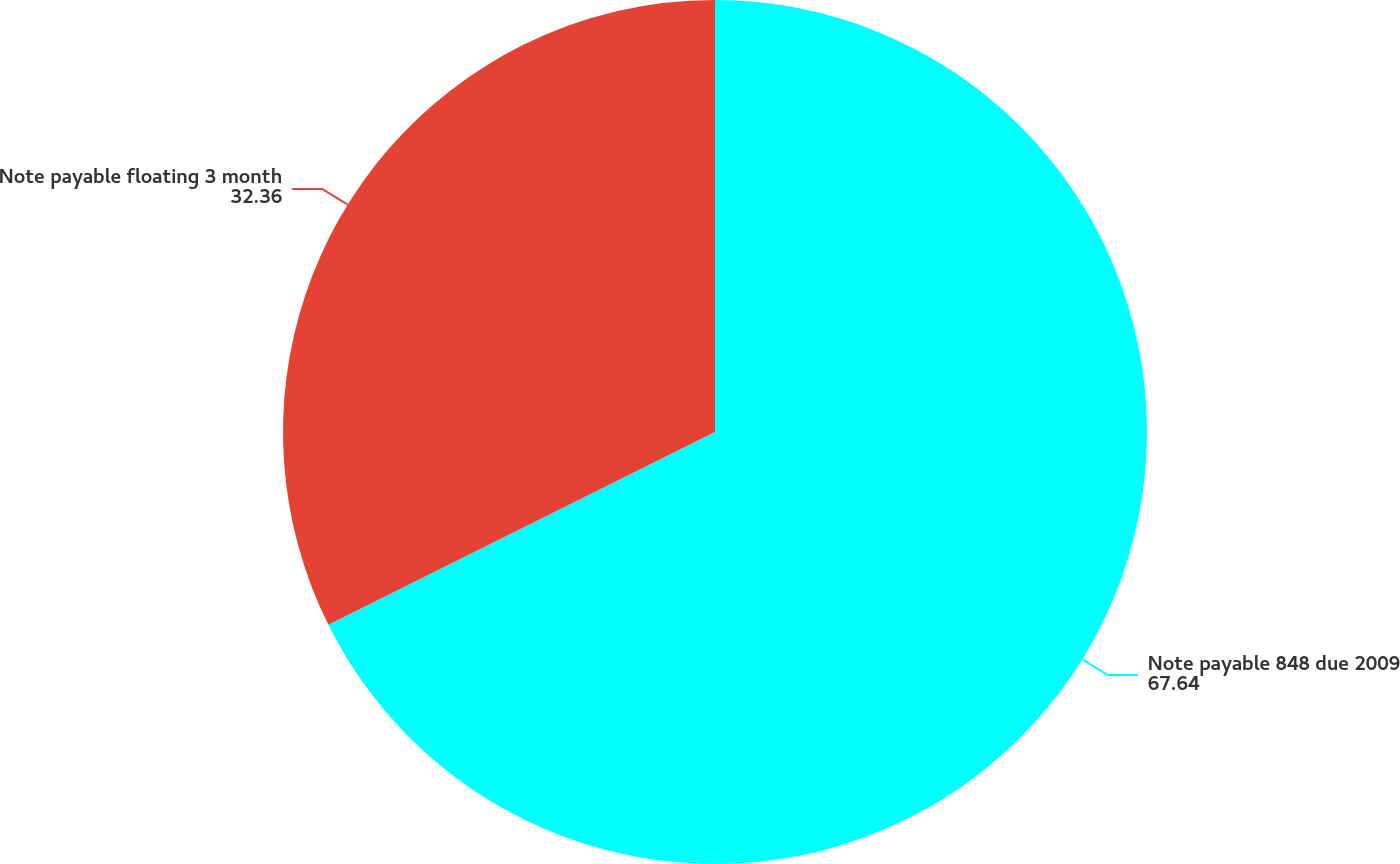<chart> <loc_0><loc_0><loc_500><loc_500><pie_chart><fcel>Note payable 848 due 2009<fcel>Note payable floating 3 month<nl><fcel>67.64%<fcel>32.36%<nl></chart> 